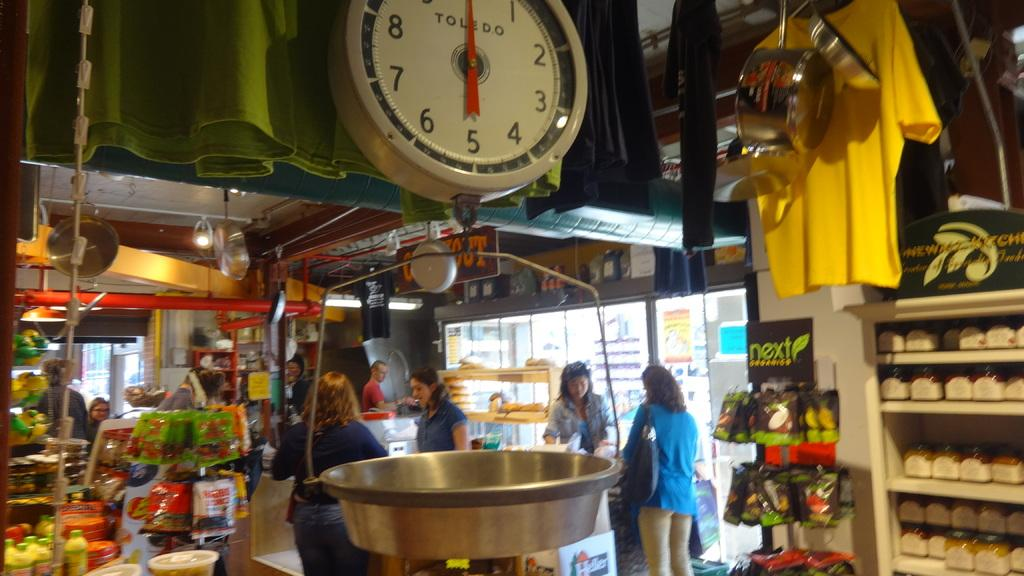Provide a one-sentence caption for the provided image. A Toledo scale hangs in the foreground of a busy market. 